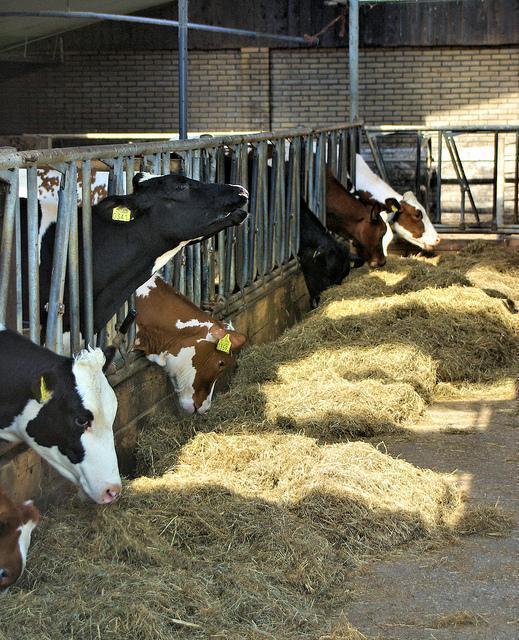Which way is the black cow with yellow tag facing?
Answer the question by selecting the correct answer among the 4 following choices.
Options: West, forward, south, down. West. 